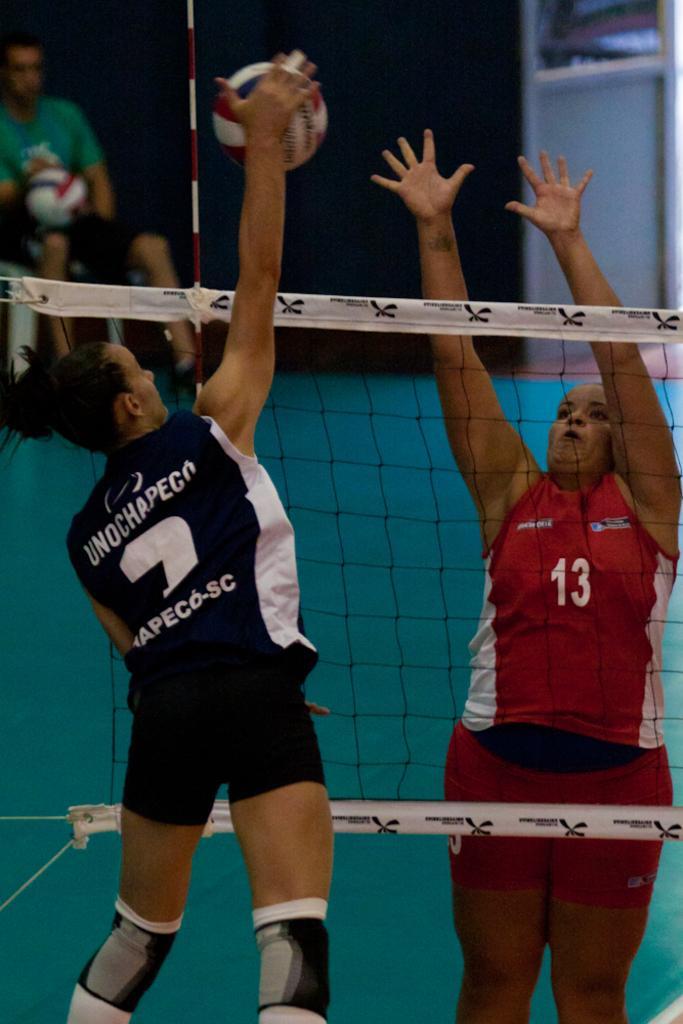Could you give a brief overview of what you see in this image? In this picture we can see three people, walls, net and in the background we can see some objects. 